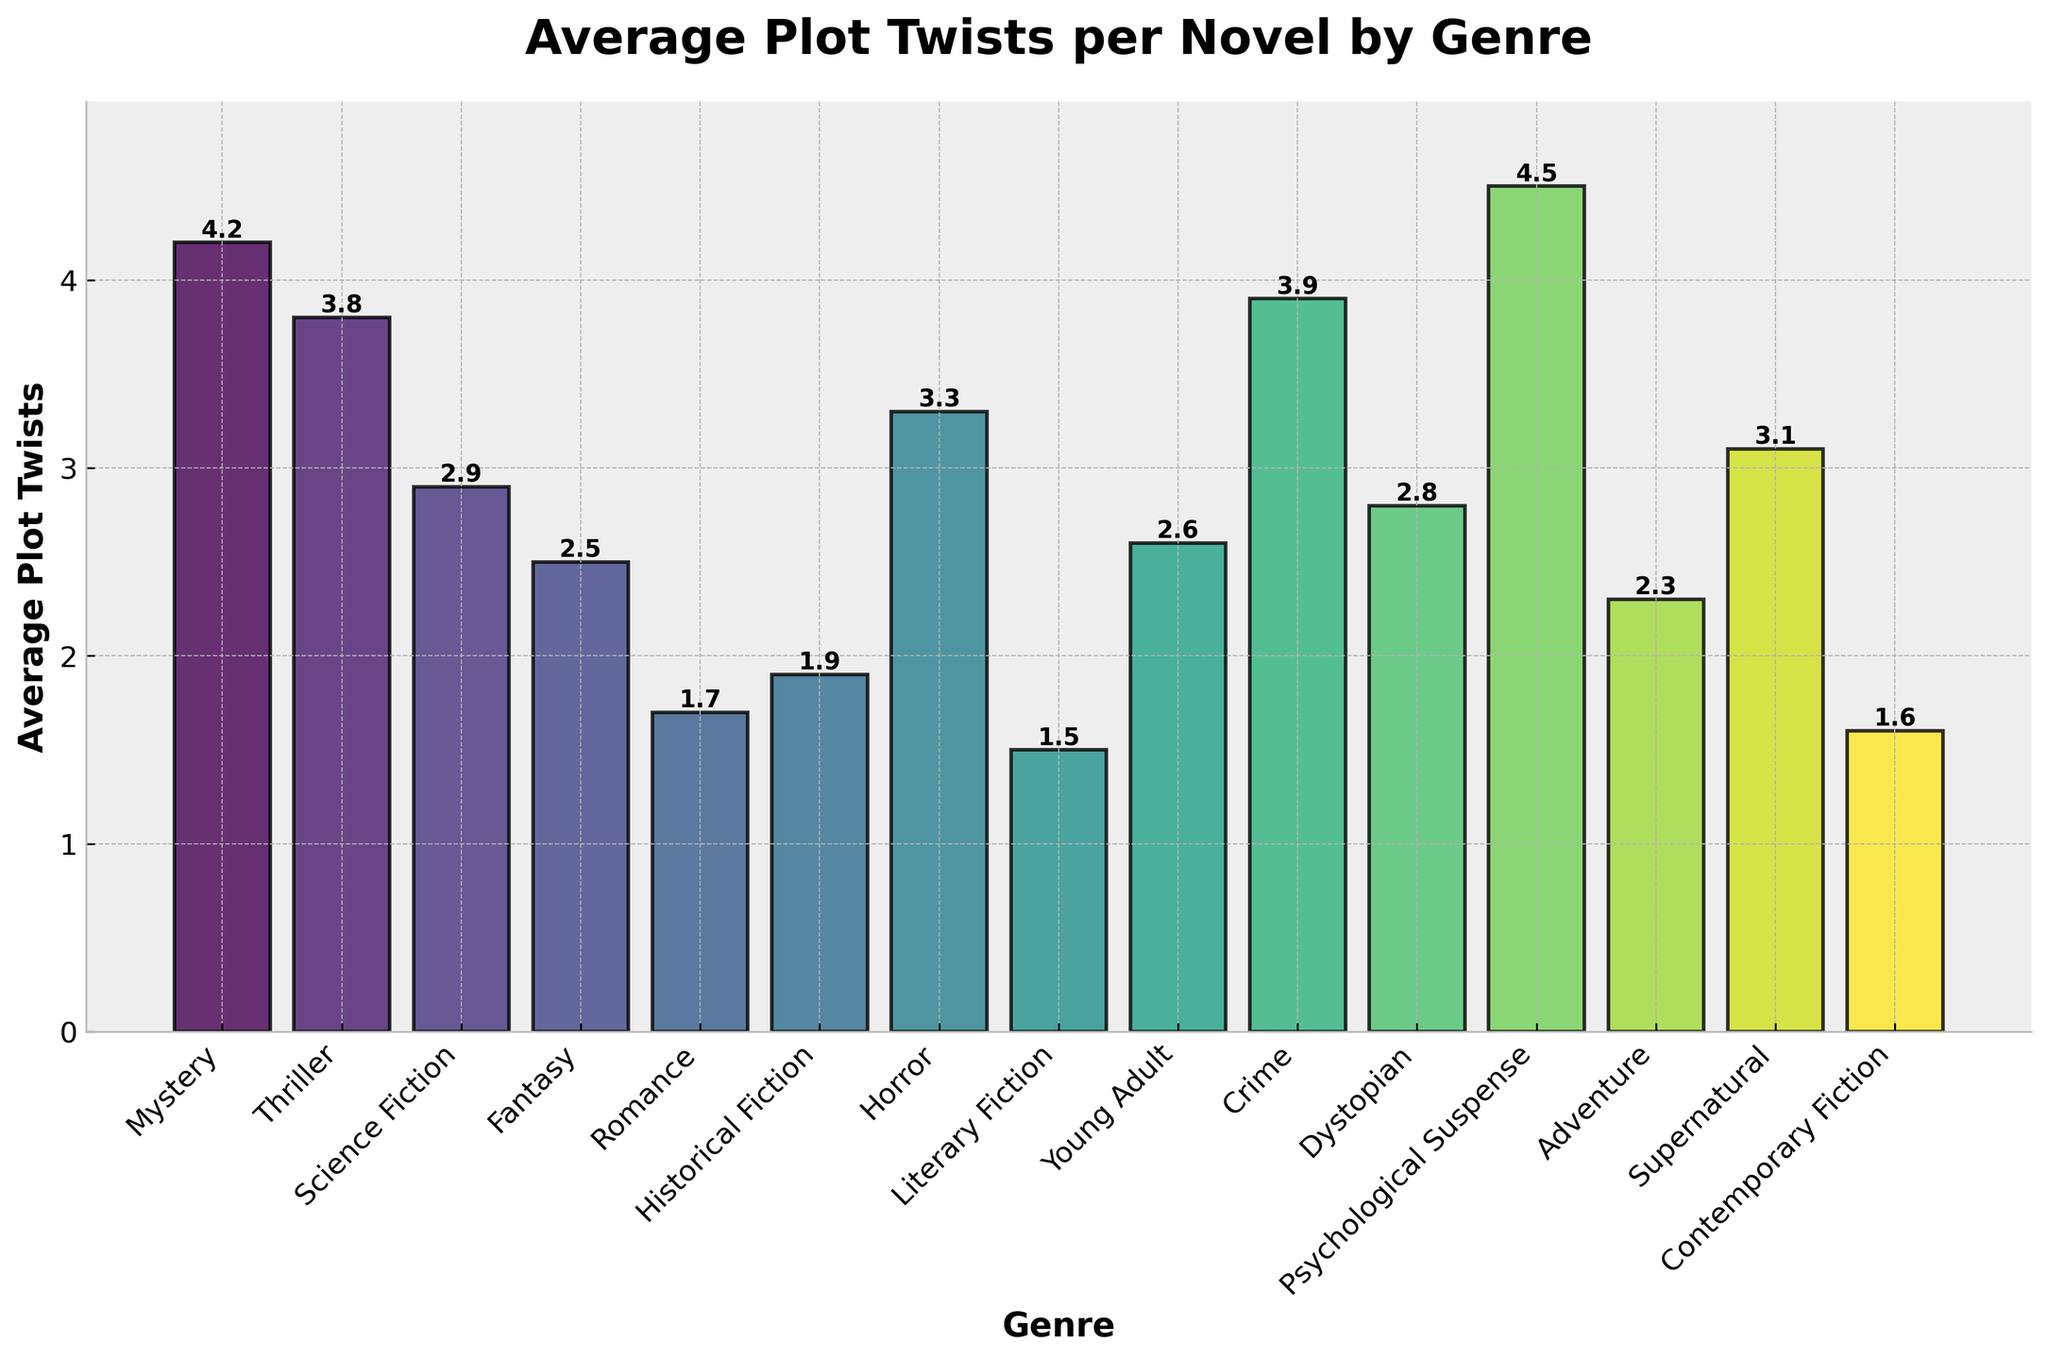What genre has the highest number of average plot twists per novel? The bar for Psychological Suspense is the tallest, indicating it has the highest number of average plot twists per novel, at 4.5.
Answer: Psychological Suspense Which genre has the least number of average plot twists per novel? The bar for Literary Fiction is the shortest, indicating it has the least number of average plot twists per novel, at 1.5.
Answer: Literary Fiction How many more average plot twists does Mystery have compared to Romance? Mystery has 4.2 average plot twists, while Romance has 1.7. Subtracting them gives 4.2 - 1.7 = 2.5.
Answer: 2.5 Which genres have an average of more than 3 plot twists per novel? Looking at the bars above the line marking 3 plot twists, the genres are Mystery, Thriller, Horror, Crime, Psychological Suspense, and Supernatural.
Answer: Mystery, Thriller, Horror, Crime, Psychological Suspense, Supernatural Are there any genres with exactly 2 average plot twists per novel? None of the bars align exactly with the 2 plot twists mark.
Answer: No What is the difference in average plot twists between Horror and Adventure? Horror has 3.3 average plot twists, and Adventure has 2.3. Subtracting them gives 3.3 - 2.3 = 1.0.
Answer: 1.0 Which two genres have nearly the same number of average plot twists per novel? Fantasy with 2.5 and Young Adult with 2.6 have nearly the same number of average plot twists per novel.
Answer: Fantasy, Young Adult What is the average number of plot twists for Science Fiction, Fantasy, and Adventure combined? Adding up the plot twists for these genres: 2.9 (Science Fiction) + 2.5 (Fantasy) + 2.3 (Adventure) = 7.7. Dividing by 3 gives 7.7 / 3 ≈ 2.57.
Answer: 2.57 How much higher is the average number of plot twists in Crime compared to Dystopian? Crime has 3.9 average plot twists, while Dystopian has 2.8. Subtracting them gives 3.9 - 2.8 = 1.1.
Answer: 1.1 